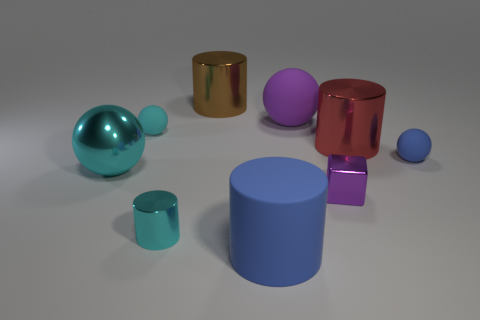Can you describe the color palette of the objects? Certainly. The objects in the image feature a color palette that includes a metallic gold, a matte purple, a shiny red, a pastel turquoise, and a muted blue. How do the colors contribute to the image's overall aesthetic? The varying colors add depth and appeal to the image. The metallic sheen of the gold object adds a touch of luxury, the red and purple provide a strong visual contrast, and the softer blues give a calming effect, creating a balanced and visually stimulating composition. 